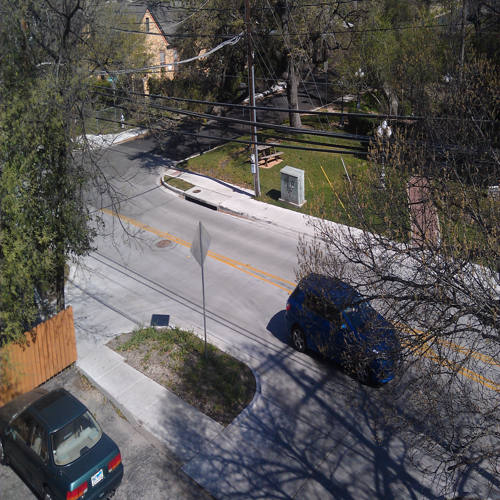How does this image reflect the pace of life in this neighborhood? The stillness of the cars and the absence of people suggest a peaceful and slow-paced environment, typical of a residential suburb. The serene setting hints at a relaxed lifestyle of the inhabitants, with the opportunity for quiet living away from the hustle and bustle of busier urban areas. 